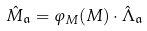<formula> <loc_0><loc_0><loc_500><loc_500>\hat { M } _ { \mathfrak { a } } = \varphi _ { M } ( M ) \cdot \hat { \Lambda } _ { \mathfrak { a } }</formula> 